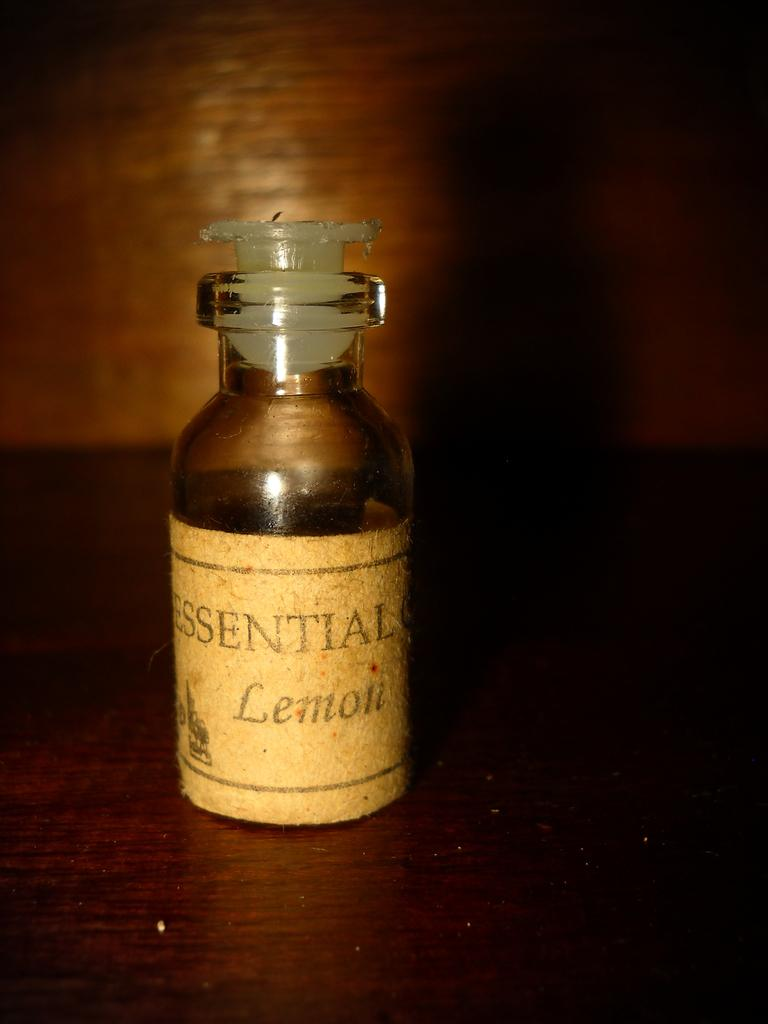<image>
Provide a brief description of the given image. A small bottle with a cork that contains essential lemon. 